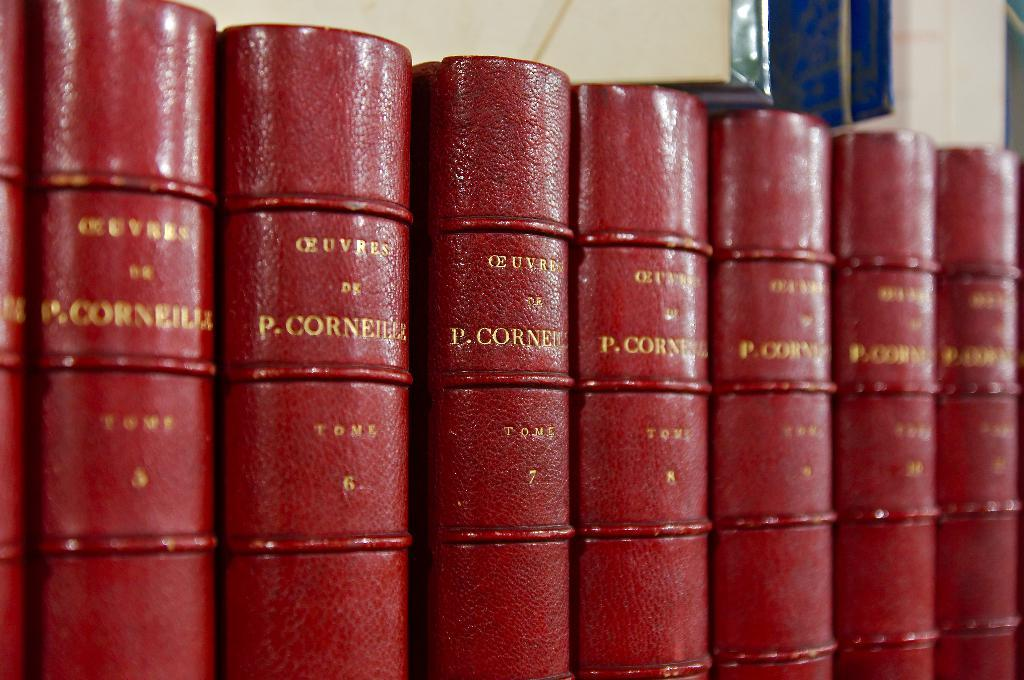<image>
Present a compact description of the photo's key features. P is the initial of the author of this collection of books. 